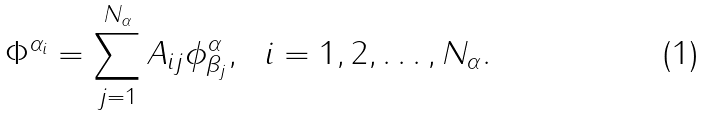Convert formula to latex. <formula><loc_0><loc_0><loc_500><loc_500>\Phi ^ { \alpha _ { i } } = \sum _ { j = 1 } ^ { N _ { \alpha } } A _ { i j } \phi ^ { \alpha } _ { \beta _ { j } } , \ \ i = 1 , 2 , \dots , N _ { \alpha } .</formula> 